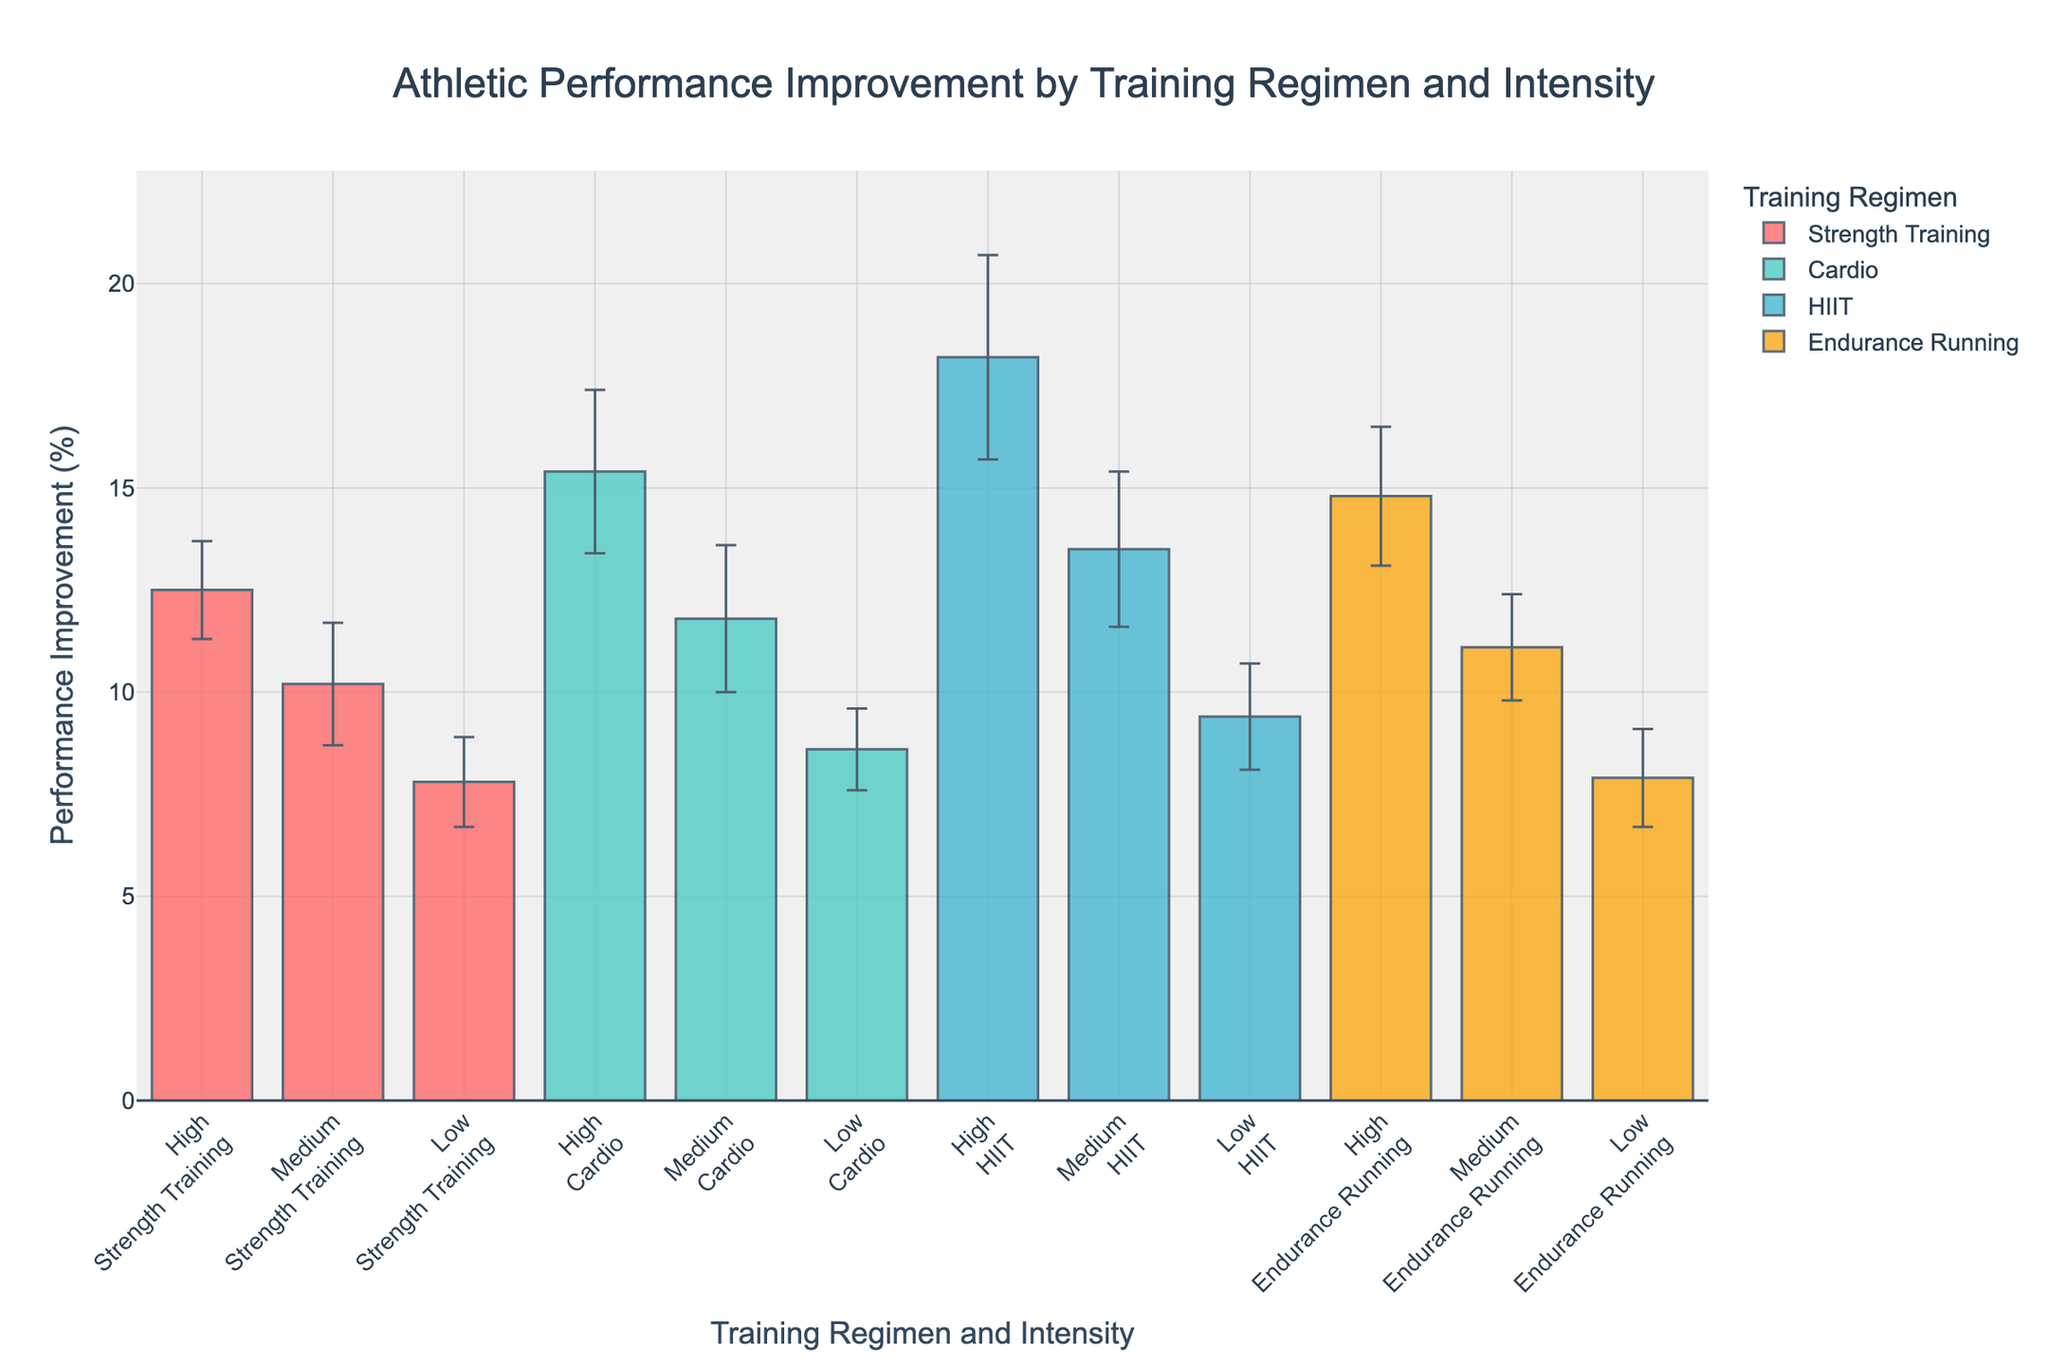How many training intensity levels are represented in the figure? The x-axis shows different training intensities, and the labels indicate three distinct levels: High, Medium, and Low.
Answer: 3 What is the title of the figure? The title is at the top of the figure and reads "Athletic Performance Improvement by Training Regimen and Intensity".
Answer: Athletic Performance Improvement by Training Regimen and Intensity Which training regimen has the highest performance improvement percentage for High intensity? Looking at the bars for High intensity, the tallest bar corresponds to the HIIT training regimen, with a performance improvement of 18.2%.
Answer: HIIT Compare the performance improvement percentage of Jane Smith's Cardio regimen at High and Low intensity. What's the difference? For Jane Smith's Cardio regimen, the High intensity improvement is 15.4% and the Low intensity is 8.6%. The difference is 15.4% - 8.6% = 6.8%.
Answer: 6.8% What is the average performance improvement percentage for Strength Training across all intensities? The performance improvements for Strength Training are 12.5% (High), 10.2% (Medium), and 7.8% (Low). The average is (12.5 + 10.2 + 7.8) / 3 ≈ 10.17.
Answer: 10.17 Which regimen shows the smallest error bar at High intensity? The error bars for High intensity need to be checked for each regimen. The smallest error bar is for Strength Training, where the error is 1.2.
Answer: Strength Training Who shows the highest overall performance improvement percentage, and under which regimen and intensity? By comparing the bars of all athletes, Mike Johnson with HIIT at High intensity has the highest performance improvement of 18.2%.
Answer: Mike Johnson, HIIT, High Between John's Medium intensity Strength Training and Emily's Medium intensity Endurance Running, which athlete shows higher performance improvement, and by how much? John's Medium intensity Strength Training has an improvement of 10.2%, and Emily's Medium intensity Endurance Running has an improvement of 11.1%. The difference is 11.1% - 10.2% = 0.9%.
Answer: Emily, 0.9 What is the total performance improvement for Jane Smith across all intensities in the Cardio regimen? The performance improvements for Jane Smith's Cardio regimen are 15.4% (High), 11.8% (Medium), and 8.6% (Low). The total is 15.4 + 11.8 + 8.6 = 35.8%.
Answer: 35.8 Calculate the range of performance improvement percentages for Emily Clark's Endurance Running regimen across all intensities. The performance improvements range from 14.8% (High) to 7.9% (Low). The range is 14.8% - 7.9% = 6.9%.
Answer: 6.9% 